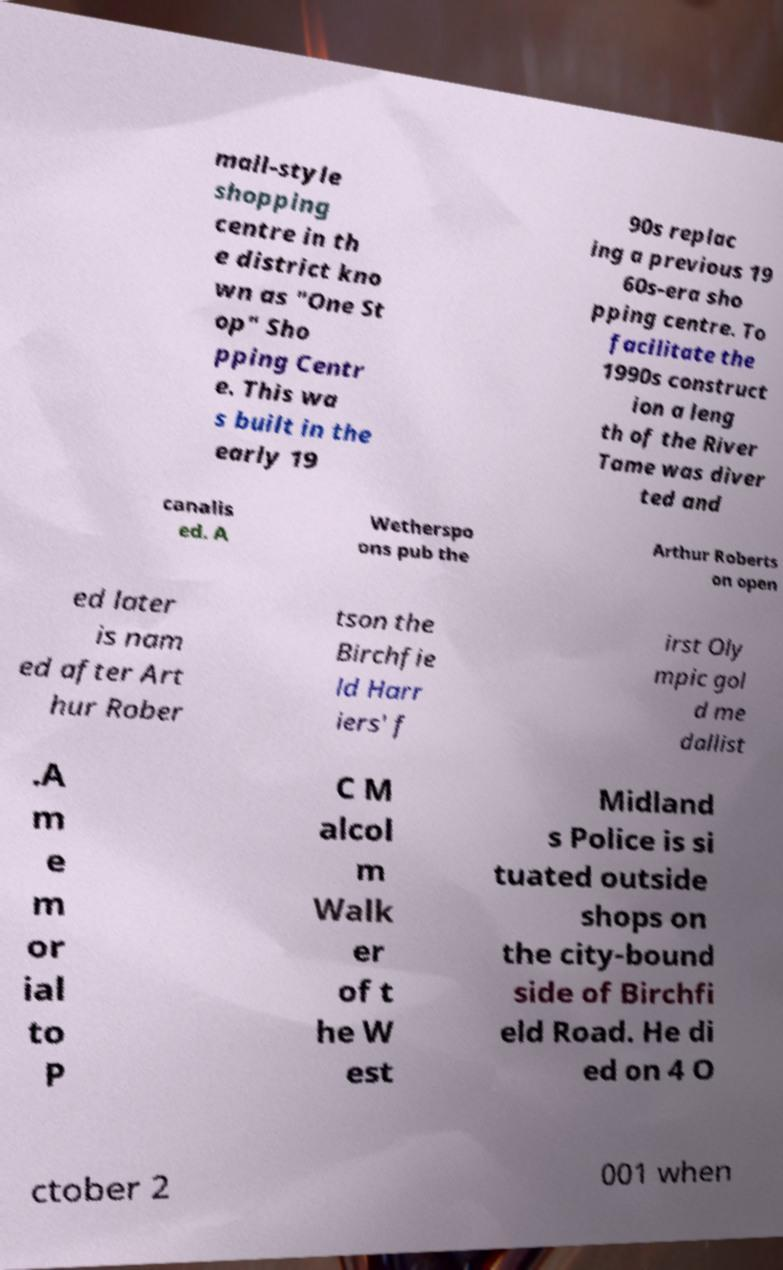For documentation purposes, I need the text within this image transcribed. Could you provide that? mall-style shopping centre in th e district kno wn as "One St op" Sho pping Centr e. This wa s built in the early 19 90s replac ing a previous 19 60s-era sho pping centre. To facilitate the 1990s construct ion a leng th of the River Tame was diver ted and canalis ed. A Wetherspo ons pub the Arthur Roberts on open ed later is nam ed after Art hur Rober tson the Birchfie ld Harr iers' f irst Oly mpic gol d me dallist .A m e m or ial to P C M alcol m Walk er of t he W est Midland s Police is si tuated outside shops on the city-bound side of Birchfi eld Road. He di ed on 4 O ctober 2 001 when 